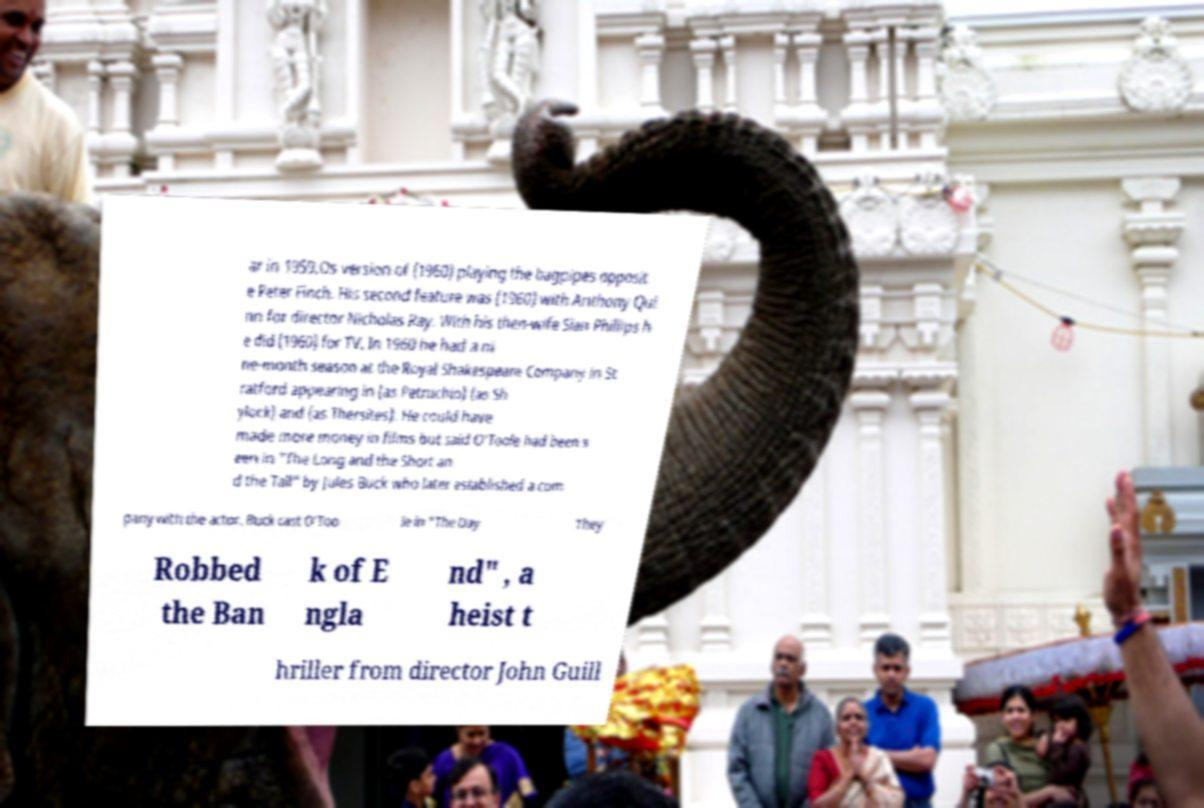There's text embedded in this image that I need extracted. Can you transcribe it verbatim? ar in 1959.Os version of (1960) playing the bagpipes opposit e Peter Finch. His second feature was (1960) with Anthony Qui nn for director Nicholas Ray. With his then-wife Sian Phillips h e did (1960) for TV. In 1960 he had a ni ne-month season at the Royal Shakespeare Company in St ratford appearing in (as Petruchio) (as Sh ylock) and (as Thersites). He could have made more money in films but said O'Toole had been s een in "The Long and the Short an d the Tall" by Jules Buck who later established a com pany with the actor. Buck cast O'Too le in "The Day They Robbed the Ban k of E ngla nd" , a heist t hriller from director John Guill 